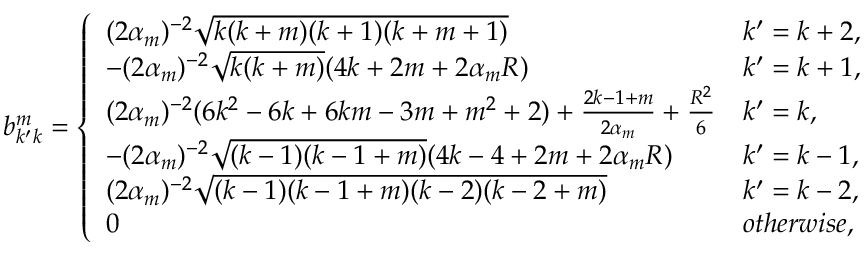<formula> <loc_0><loc_0><loc_500><loc_500>b _ { k ^ { \prime } k } ^ { m } = \left \{ \begin{array} { l l } { ( 2 \alpha _ { m } ) ^ { - 2 } \sqrt { k ( k + m ) ( k + 1 ) ( k + m + 1 ) } } & { k ^ { \prime } = k + 2 , } \\ { - ( 2 \alpha _ { m } ) ^ { - 2 } \sqrt { k ( k + m ) } ( 4 k + 2 m + 2 \alpha _ { m } R ) } & { k ^ { \prime } = k + 1 , } \\ { ( 2 \alpha _ { m } ) ^ { - 2 } ( 6 k ^ { 2 } - 6 k + 6 k m - 3 m + m ^ { 2 } + 2 ) + \frac { 2 k - 1 + m } { 2 \alpha _ { m } } + \frac { R ^ { 2 } } { 6 } } & { k ^ { \prime } = k , } \\ { - ( 2 \alpha _ { m } ) ^ { - 2 } \sqrt { ( k - 1 ) ( k - 1 + m ) } ( 4 k - 4 + 2 m + 2 \alpha _ { m } R ) } & { k ^ { \prime } = k - 1 , } \\ { ( 2 \alpha _ { m } ) ^ { - 2 } \sqrt { ( k - 1 ) ( k - 1 + m ) ( k - 2 ) ( k - 2 + m ) } } & { k ^ { \prime } = k - 2 , } \\ { 0 } & { o t h e r w i s e , } \end{array}</formula> 